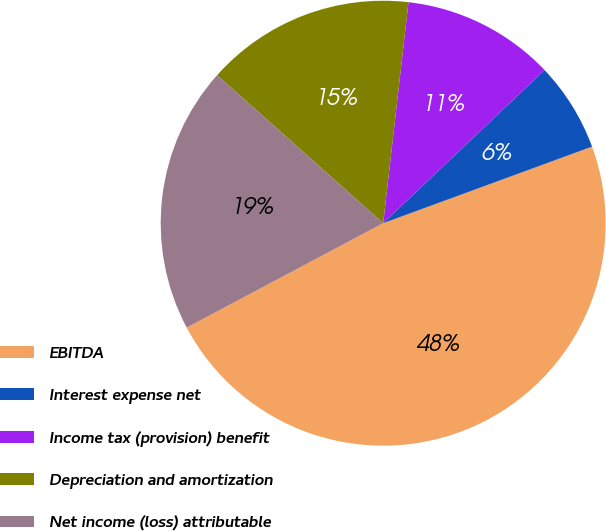<chart> <loc_0><loc_0><loc_500><loc_500><pie_chart><fcel>EBITDA<fcel>Interest expense net<fcel>Income tax (provision) benefit<fcel>Depreciation and amortization<fcel>Net income (loss) attributable<nl><fcel>47.82%<fcel>6.49%<fcel>11.1%<fcel>15.23%<fcel>19.36%<nl></chart> 